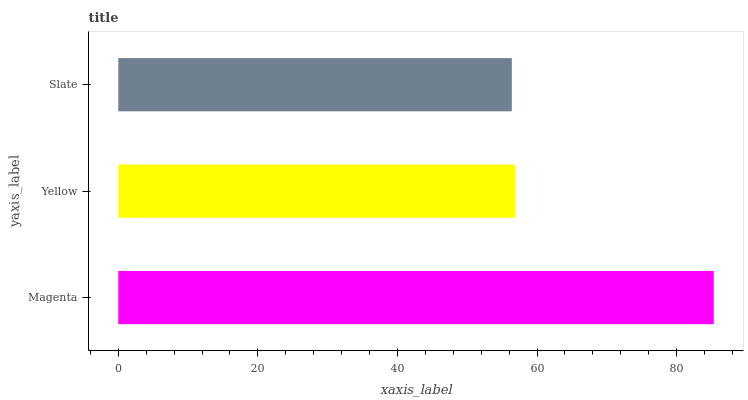Is Slate the minimum?
Answer yes or no. Yes. Is Magenta the maximum?
Answer yes or no. Yes. Is Yellow the minimum?
Answer yes or no. No. Is Yellow the maximum?
Answer yes or no. No. Is Magenta greater than Yellow?
Answer yes or no. Yes. Is Yellow less than Magenta?
Answer yes or no. Yes. Is Yellow greater than Magenta?
Answer yes or no. No. Is Magenta less than Yellow?
Answer yes or no. No. Is Yellow the high median?
Answer yes or no. Yes. Is Yellow the low median?
Answer yes or no. Yes. Is Magenta the high median?
Answer yes or no. No. Is Magenta the low median?
Answer yes or no. No. 